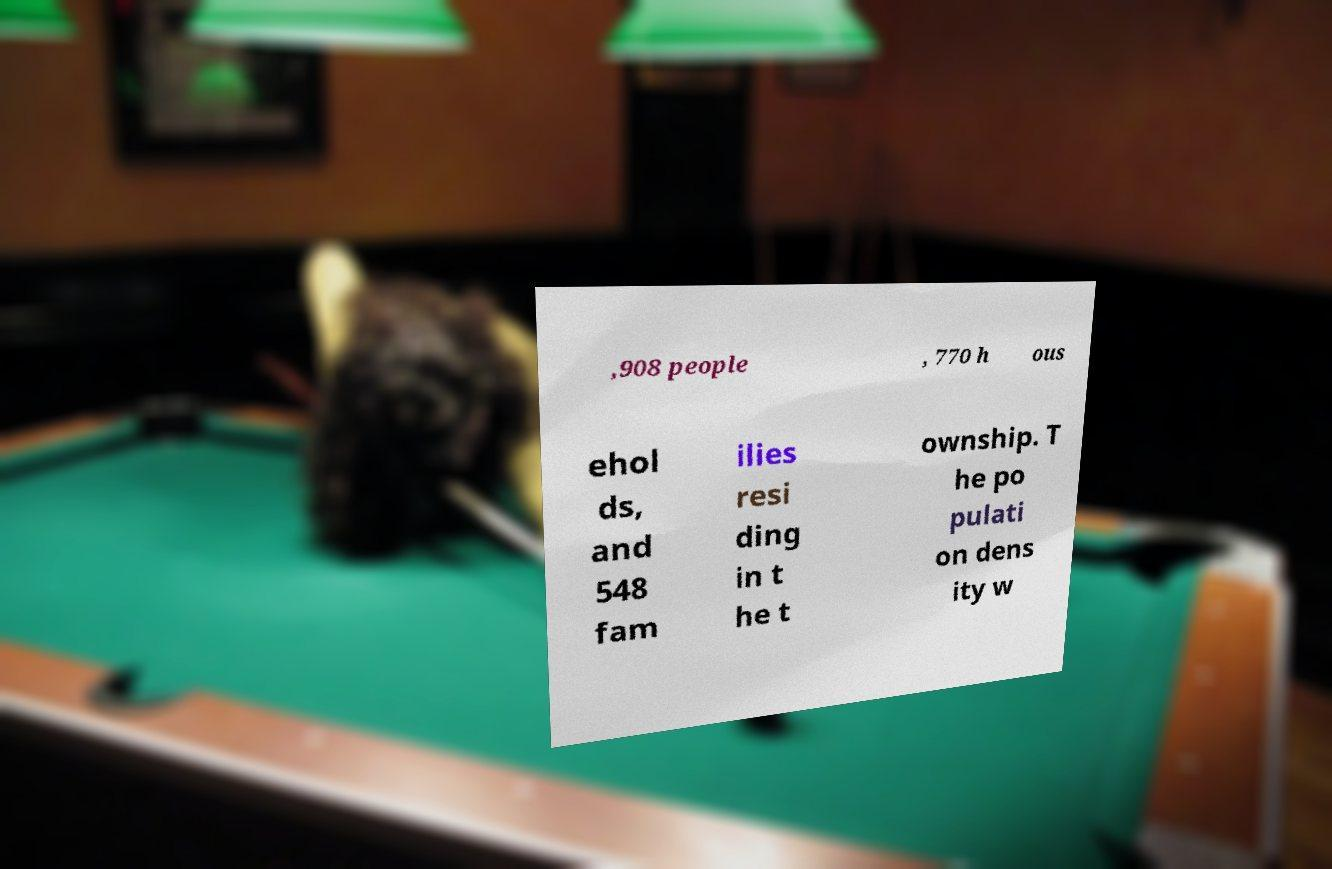What messages or text are displayed in this image? I need them in a readable, typed format. ,908 people , 770 h ous ehol ds, and 548 fam ilies resi ding in t he t ownship. T he po pulati on dens ity w 